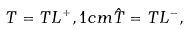Convert formula to latex. <formula><loc_0><loc_0><loc_500><loc_500>T = T L ^ { + } , 1 c m \hat { T } = T L ^ { - } ,</formula> 